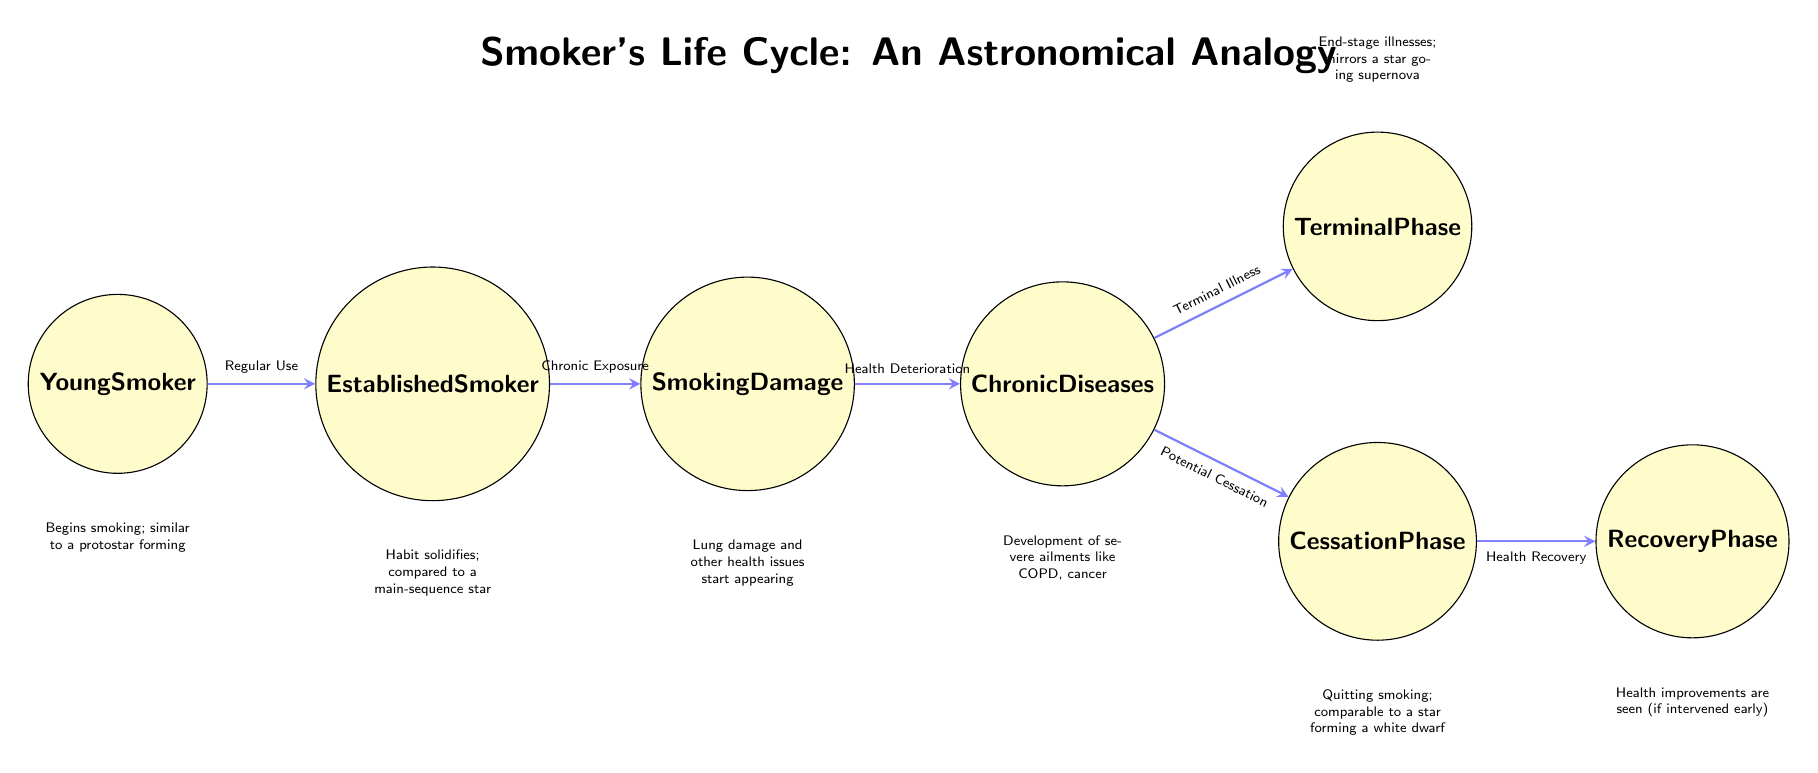What is the first phase of a smoker's life according to the diagram? The first phase is labeled "Young Smoker." This is identified by looking at the leftmost node in the diagram.
Answer: Young Smoker What follows after "Established Smoker"? The next phase after "Established Smoker" is "Smoking Damage," which is indicated by the direct edge leading from "Established Smoker" to "Smoking Damage."
Answer: Smoking Damage How many phases are there in the smoking life cycle shown? By counting the distinct nodes in the diagram, there are a total of seven phases. Each node represents a specific phase in the smoker’s life.
Answer: 7 What analogy is drawn for the "Cessation Phase"? The "Cessation Phase" is compared to a star forming a white dwarf. This analogy is explicitly mentioned in the text below the "Cessation Phase" node.
Answer: A star forming a white dwarf What is the consequence of the "Chronic Diseases" phase? The consequence is the development of severe ailments like COPD and cancer, as detailed in the description under the "Chronic Diseases" node.
Answer: Development of severe ailments like COPD, cancer What transition occurs from "Chronic Diseases" to "Terminal Phase"? The transition is due to "Terminal Illness," which is the connecting label moving from "Chronic Diseases" to "Terminal Phase." This denotes a progression into a more severe health condition.
Answer: Terminal Illness Which phase specifically refers to improvement in health? The phase that refers to improvement in health is the "Recovery Phase," as indicated in the description below that node.
Answer: Recovery Phase How does the diagram characterize the state of a "Young Smoker"? The diagram characterizes a "Young Smoker" as beginning to smoke, which is compared to a protostar forming. This comparison is stated directly beneath the "Young Smoker" node.
Answer: Similar to a protostar forming 